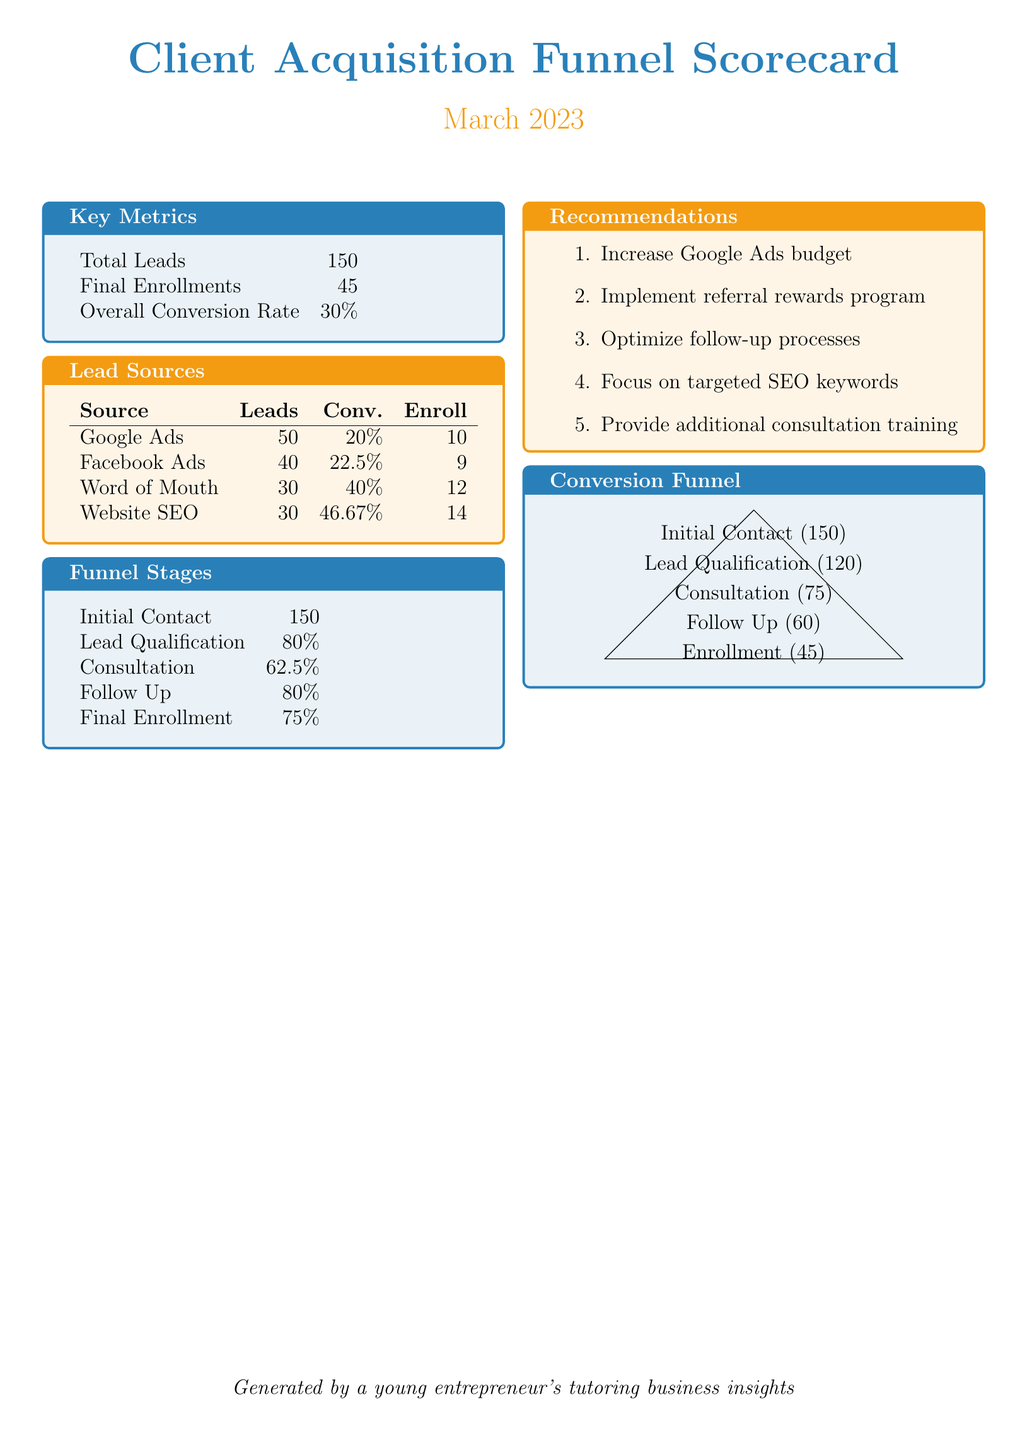What is the total number of leads? The total number of leads is provided in the key metrics section of the document.
Answer: 150 What is the conversion rate for website SEO? The conversion rate for website SEO is listed in the lead sources table.
Answer: 46.67% How many leads come from Facebook Ads? The number of leads from Facebook Ads is specified in the lead sources table.
Answer: 40 What recommendation is made regarding the Google Ads budget? The recommendations section mentions a specific action regarding the Google Ads budget.
Answer: Increase What is the enrollment number from Word of Mouth? The enrollment number from Word of Mouth is detailed in the lead sources table.
Answer: 12 What percentage of leads make it to the consultation stage? The percentage of leads that advance to the consultation stage is indicated in the funnel stages section.
Answer: 62.5% Which lead source has the highest conversion rate? The lead source with the highest conversion rate can be identified from the lead sources table.
Answer: Website SEO How many successful enrollments are achieved? The total number of successful enrollments is found in the key metrics section of the document.
Answer: 45 What is the final conversion rate across all leads? The overall conversion rate is stated in the key metrics section.
Answer: 30% 